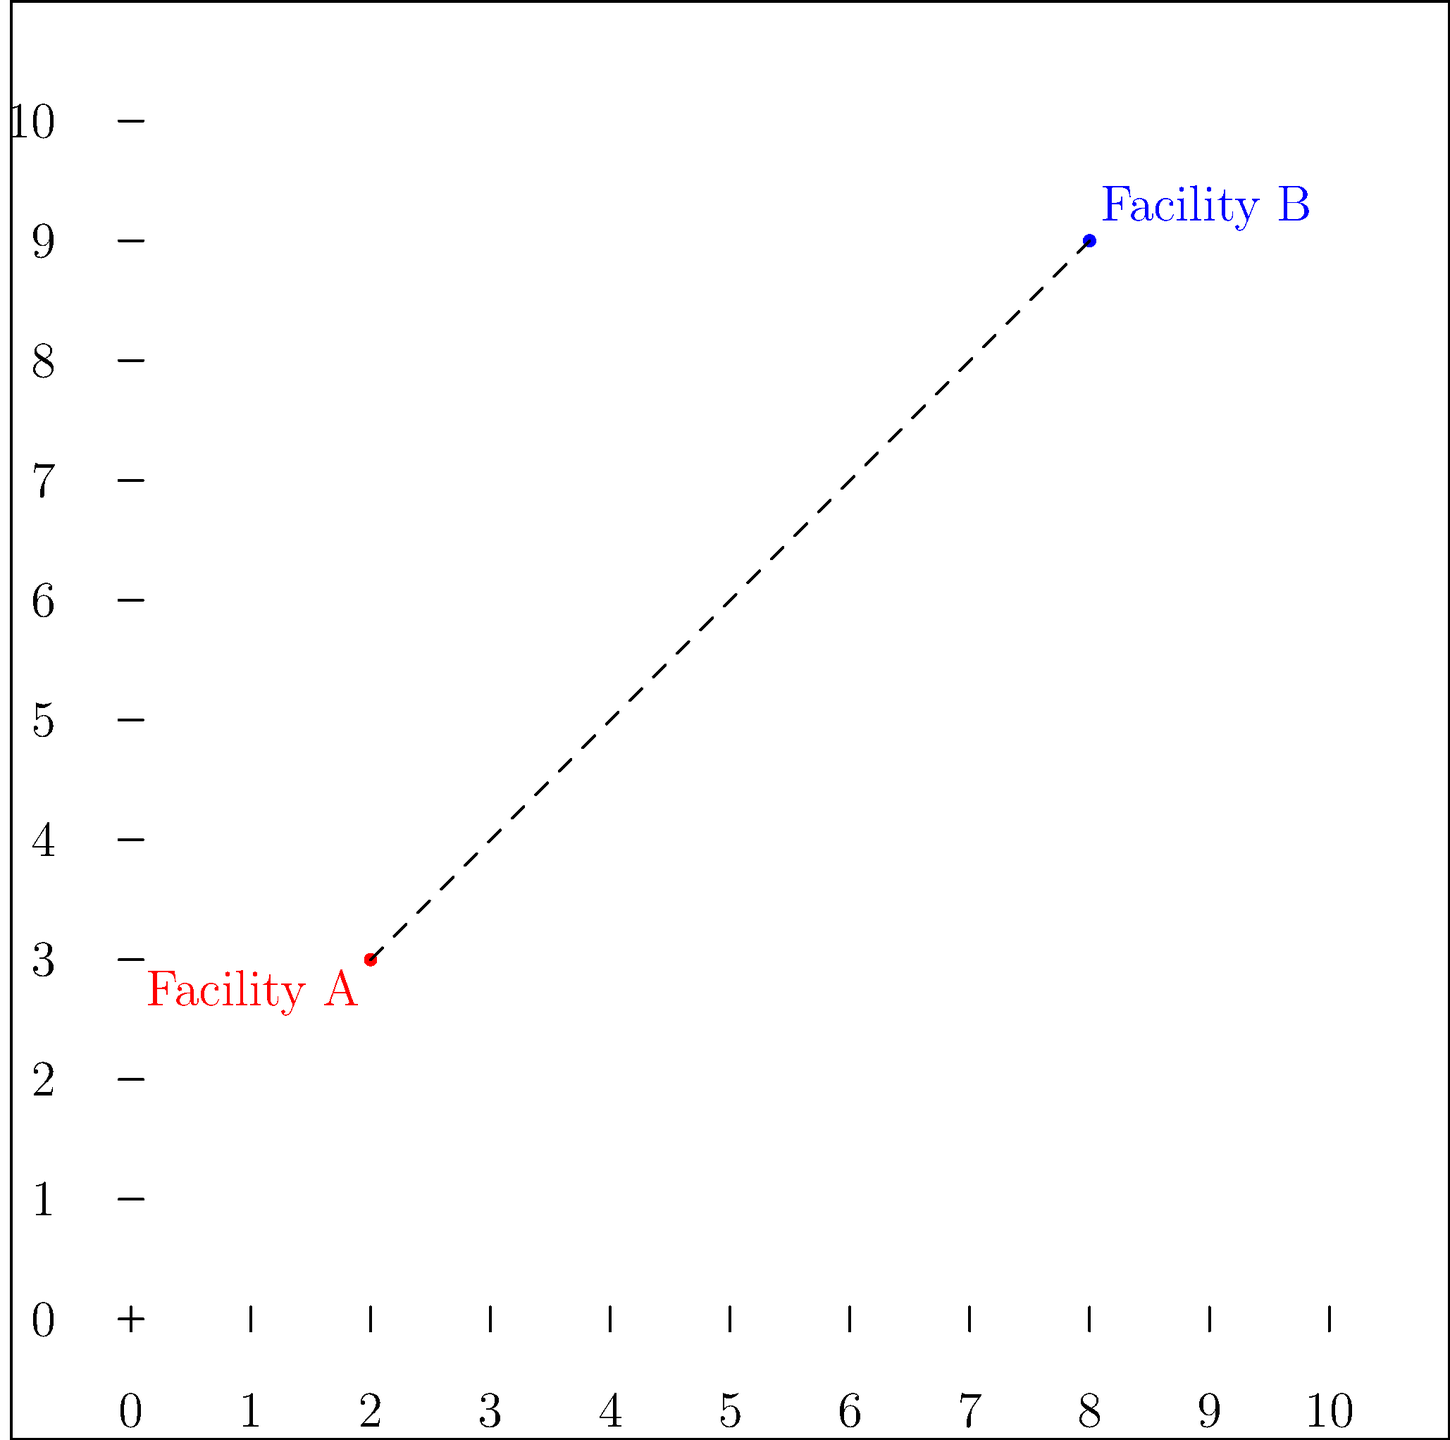As a regulatory affairs specialist, you're tasked with analyzing the geographical distribution of healthcare facilities. On a map grid where each unit represents 1 mile, Facility A is located at coordinates (2, 3) and Facility B is at (8, 9). Calculate the straight-line distance between these two facilities to determine if they meet the minimum distance requirement for healthcare facility spacing. To calculate the straight-line distance between two points on a coordinate plane, we can use the distance formula, which is derived from the Pythagorean theorem:

$$d = \sqrt{(x_2 - x_1)^2 + (y_2 - y_1)^2}$$

Where:
$(x_1, y_1)$ are the coordinates of the first point (Facility A)
$(x_2, y_2)$ are the coordinates of the second point (Facility B)

Let's plug in our values:
Facility A: $(x_1, y_1) = (2, 3)$
Facility B: $(x_2, y_2) = (8, 9)$

Now, let's calculate step by step:

1) $d = \sqrt{(8 - 2)^2 + (9 - 3)^2}$

2) $d = \sqrt{6^2 + 6^2}$

3) $d = \sqrt{36 + 36}$

4) $d = \sqrt{72}$

5) $d = 6\sqrt{2}$ miles

To get a decimal approximation:
6) $d \approx 8.49$ miles

Therefore, the straight-line distance between Facility A and Facility B is $6\sqrt{2}$ miles, or approximately 8.49 miles.
Answer: $6\sqrt{2}$ miles 